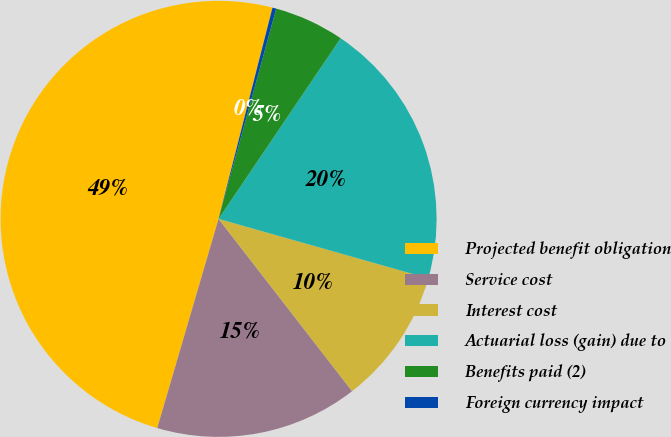Convert chart to OTSL. <chart><loc_0><loc_0><loc_500><loc_500><pie_chart><fcel>Projected benefit obligation<fcel>Service cost<fcel>Interest cost<fcel>Actuarial loss (gain) due to<fcel>Benefits paid (2)<fcel>Foreign currency impact<nl><fcel>49.44%<fcel>15.03%<fcel>10.11%<fcel>19.94%<fcel>5.2%<fcel>0.28%<nl></chart> 